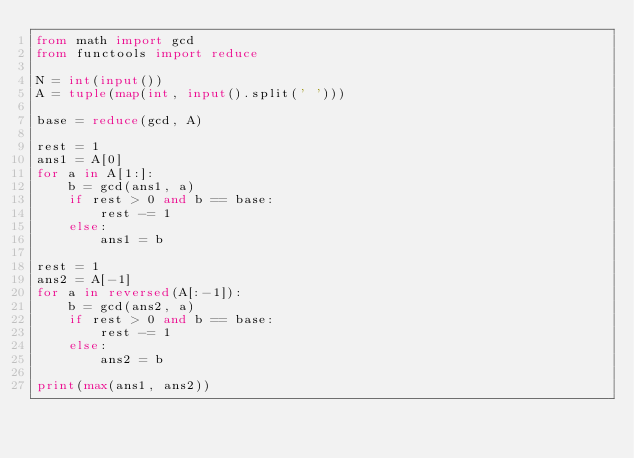Convert code to text. <code><loc_0><loc_0><loc_500><loc_500><_Python_>from math import gcd
from functools import reduce

N = int(input())
A = tuple(map(int, input().split(' ')))

base = reduce(gcd, A)

rest = 1
ans1 = A[0]
for a in A[1:]:
    b = gcd(ans1, a)
    if rest > 0 and b == base:
        rest -= 1
    else:
        ans1 = b

rest = 1
ans2 = A[-1]
for a in reversed(A[:-1]):
    b = gcd(ans2, a)
    if rest > 0 and b == base:
        rest -= 1
    else:
        ans2 = b

print(max(ans1, ans2))
</code> 